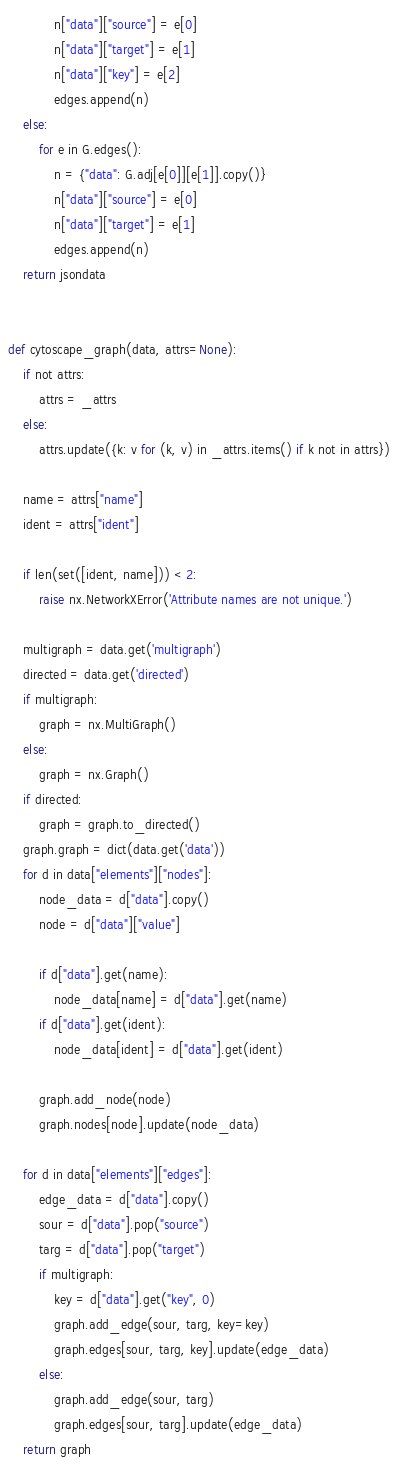<code> <loc_0><loc_0><loc_500><loc_500><_Python_>            n["data"]["source"] = e[0]
            n["data"]["target"] = e[1]
            n["data"]["key"] = e[2]
            edges.append(n)
    else:
        for e in G.edges():
            n = {"data": G.adj[e[0]][e[1]].copy()}
            n["data"]["source"] = e[0]
            n["data"]["target"] = e[1]
            edges.append(n)
    return jsondata


def cytoscape_graph(data, attrs=None):
    if not attrs:
        attrs = _attrs
    else:
        attrs.update({k: v for (k, v) in _attrs.items() if k not in attrs})

    name = attrs["name"]
    ident = attrs["ident"]

    if len(set([ident, name])) < 2:
        raise nx.NetworkXError('Attribute names are not unique.')

    multigraph = data.get('multigraph')
    directed = data.get('directed')
    if multigraph:
        graph = nx.MultiGraph()
    else:
        graph = nx.Graph()
    if directed:
        graph = graph.to_directed()
    graph.graph = dict(data.get('data'))
    for d in data["elements"]["nodes"]:
        node_data = d["data"].copy()
        node = d["data"]["value"]

        if d["data"].get(name):
            node_data[name] = d["data"].get(name)
        if d["data"].get(ident):
            node_data[ident] = d["data"].get(ident)

        graph.add_node(node)
        graph.nodes[node].update(node_data)

    for d in data["elements"]["edges"]:
        edge_data = d["data"].copy()
        sour = d["data"].pop("source")
        targ = d["data"].pop("target")
        if multigraph:
            key = d["data"].get("key", 0)
            graph.add_edge(sour, targ, key=key)
            graph.edges[sour, targ, key].update(edge_data)
        else:
            graph.add_edge(sour, targ)
            graph.edges[sour, targ].update(edge_data)
    return graph
</code> 